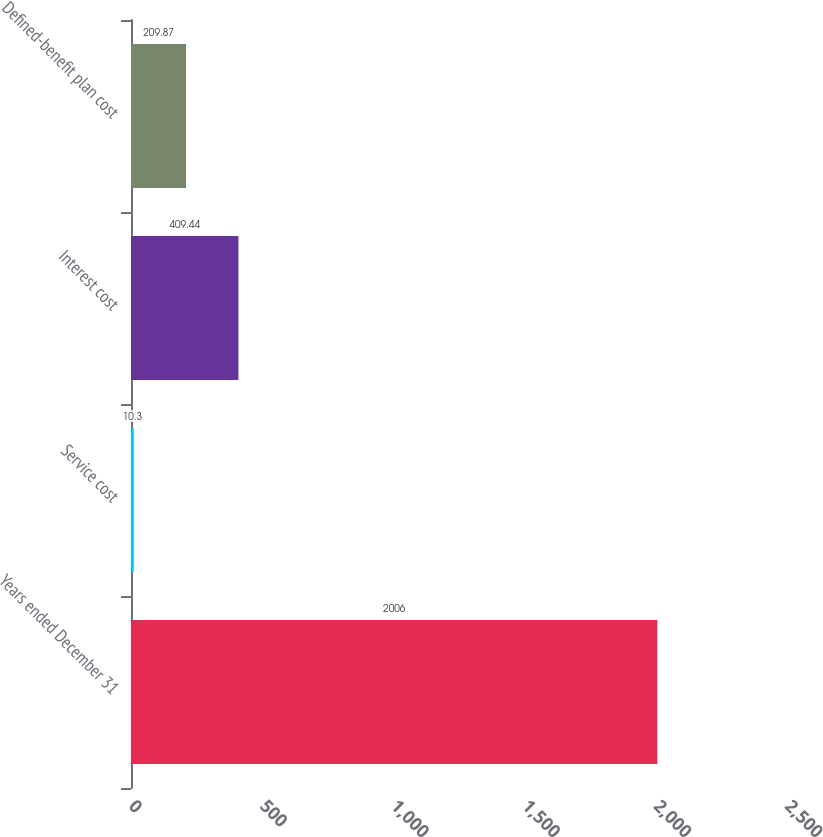Convert chart to OTSL. <chart><loc_0><loc_0><loc_500><loc_500><bar_chart><fcel>Years ended December 31<fcel>Service cost<fcel>Interest cost<fcel>Defined-benefit plan cost<nl><fcel>2006<fcel>10.3<fcel>409.44<fcel>209.87<nl></chart> 